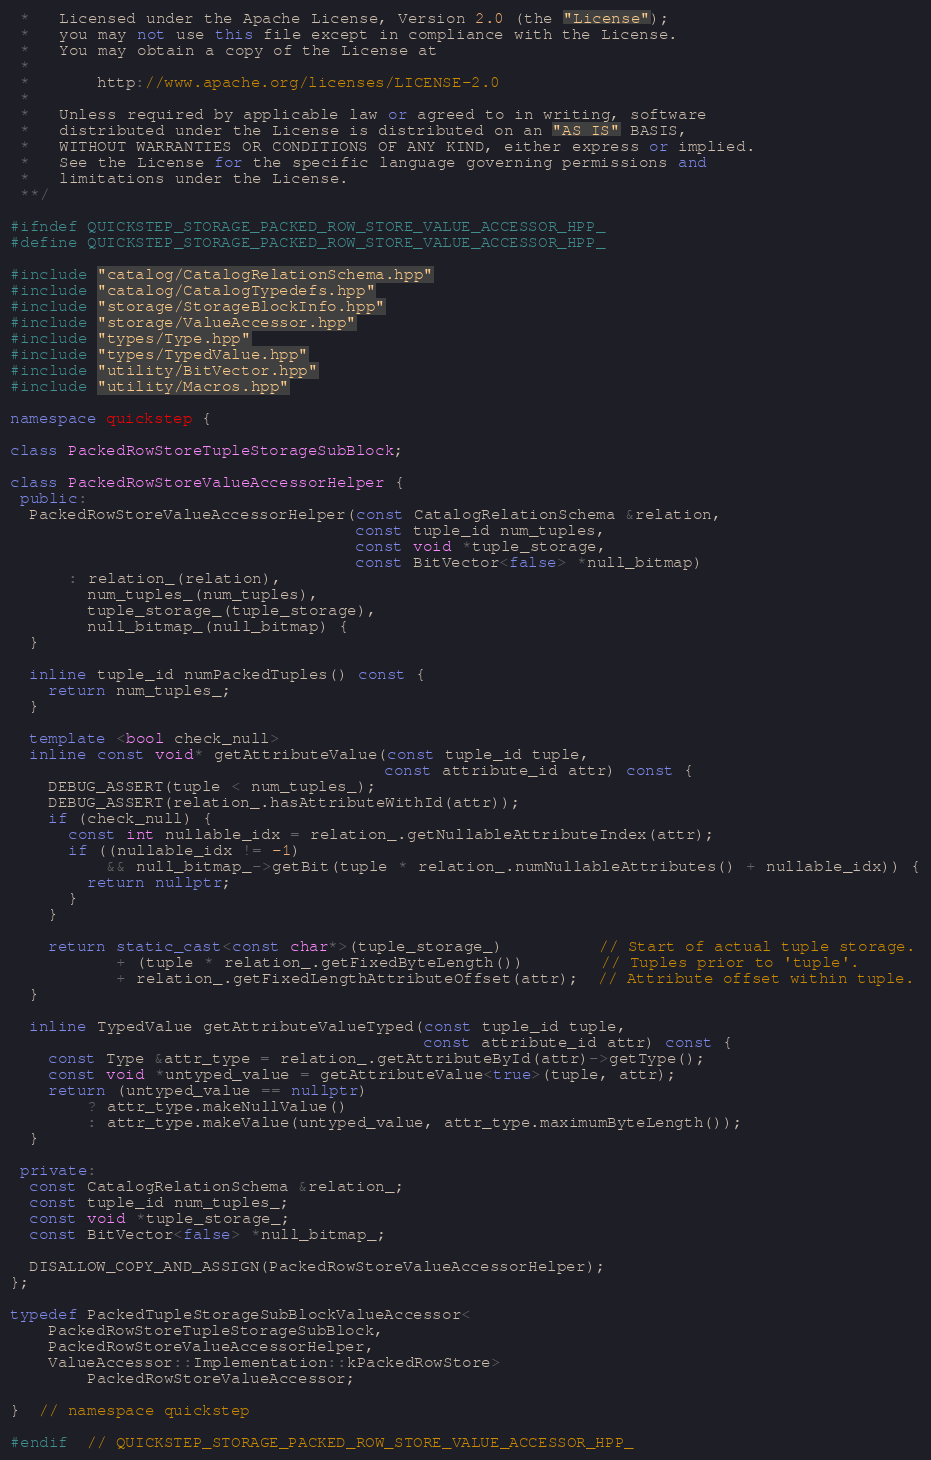<code> <loc_0><loc_0><loc_500><loc_500><_C++_> *   Licensed under the Apache License, Version 2.0 (the "License");
 *   you may not use this file except in compliance with the License.
 *   You may obtain a copy of the License at
 *
 *       http://www.apache.org/licenses/LICENSE-2.0
 *
 *   Unless required by applicable law or agreed to in writing, software
 *   distributed under the License is distributed on an "AS IS" BASIS,
 *   WITHOUT WARRANTIES OR CONDITIONS OF ANY KIND, either express or implied.
 *   See the License for the specific language governing permissions and
 *   limitations under the License.
 **/

#ifndef QUICKSTEP_STORAGE_PACKED_ROW_STORE_VALUE_ACCESSOR_HPP_
#define QUICKSTEP_STORAGE_PACKED_ROW_STORE_VALUE_ACCESSOR_HPP_

#include "catalog/CatalogRelationSchema.hpp"
#include "catalog/CatalogTypedefs.hpp"
#include "storage/StorageBlockInfo.hpp"
#include "storage/ValueAccessor.hpp"
#include "types/Type.hpp"
#include "types/TypedValue.hpp"
#include "utility/BitVector.hpp"
#include "utility/Macros.hpp"

namespace quickstep {

class PackedRowStoreTupleStorageSubBlock;

class PackedRowStoreValueAccessorHelper {
 public:
  PackedRowStoreValueAccessorHelper(const CatalogRelationSchema &relation,
                                    const tuple_id num_tuples,
                                    const void *tuple_storage,
                                    const BitVector<false> *null_bitmap)
      : relation_(relation),
        num_tuples_(num_tuples),
        tuple_storage_(tuple_storage),
        null_bitmap_(null_bitmap) {
  }

  inline tuple_id numPackedTuples() const {
    return num_tuples_;
  }

  template <bool check_null>
  inline const void* getAttributeValue(const tuple_id tuple,
                                       const attribute_id attr) const {
    DEBUG_ASSERT(tuple < num_tuples_);
    DEBUG_ASSERT(relation_.hasAttributeWithId(attr));
    if (check_null) {
      const int nullable_idx = relation_.getNullableAttributeIndex(attr);
      if ((nullable_idx != -1)
          && null_bitmap_->getBit(tuple * relation_.numNullableAttributes() + nullable_idx)) {
        return nullptr;
      }
    }

    return static_cast<const char*>(tuple_storage_)          // Start of actual tuple storage.
           + (tuple * relation_.getFixedByteLength())        // Tuples prior to 'tuple'.
           + relation_.getFixedLengthAttributeOffset(attr);  // Attribute offset within tuple.
  }

  inline TypedValue getAttributeValueTyped(const tuple_id tuple,
                                           const attribute_id attr) const {
    const Type &attr_type = relation_.getAttributeById(attr)->getType();
    const void *untyped_value = getAttributeValue<true>(tuple, attr);
    return (untyped_value == nullptr)
        ? attr_type.makeNullValue()
        : attr_type.makeValue(untyped_value, attr_type.maximumByteLength());
  }

 private:
  const CatalogRelationSchema &relation_;
  const tuple_id num_tuples_;
  const void *tuple_storage_;
  const BitVector<false> *null_bitmap_;

  DISALLOW_COPY_AND_ASSIGN(PackedRowStoreValueAccessorHelper);
};

typedef PackedTupleStorageSubBlockValueAccessor<
    PackedRowStoreTupleStorageSubBlock,
    PackedRowStoreValueAccessorHelper,
    ValueAccessor::Implementation::kPackedRowStore>
        PackedRowStoreValueAccessor;

}  // namespace quickstep

#endif  // QUICKSTEP_STORAGE_PACKED_ROW_STORE_VALUE_ACCESSOR_HPP_
</code> 